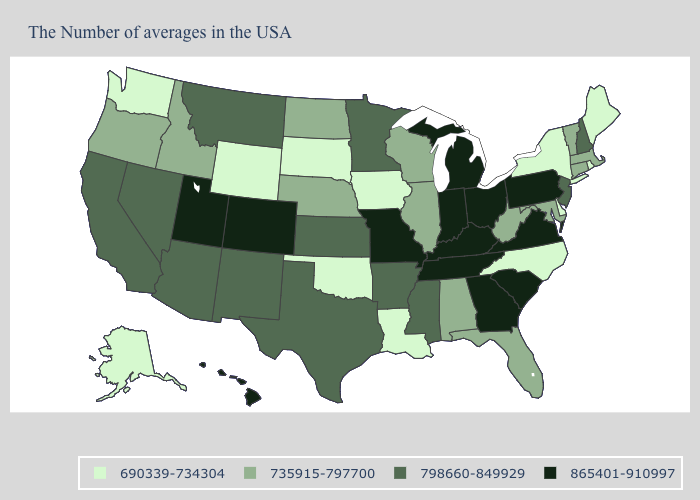Name the states that have a value in the range 865401-910997?
Concise answer only. Pennsylvania, Virginia, South Carolina, Ohio, Georgia, Michigan, Kentucky, Indiana, Tennessee, Missouri, Colorado, Utah, Hawaii. What is the value of Pennsylvania?
Keep it brief. 865401-910997. What is the value of Missouri?
Answer briefly. 865401-910997. How many symbols are there in the legend?
Be succinct. 4. Does Illinois have the same value as Vermont?
Be succinct. Yes. How many symbols are there in the legend?
Give a very brief answer. 4. Name the states that have a value in the range 735915-797700?
Short answer required. Massachusetts, Vermont, Connecticut, Maryland, West Virginia, Florida, Alabama, Wisconsin, Illinois, Nebraska, North Dakota, Idaho, Oregon. What is the highest value in the South ?
Quick response, please. 865401-910997. Which states have the highest value in the USA?
Be succinct. Pennsylvania, Virginia, South Carolina, Ohio, Georgia, Michigan, Kentucky, Indiana, Tennessee, Missouri, Colorado, Utah, Hawaii. What is the highest value in the USA?
Keep it brief. 865401-910997. What is the lowest value in the USA?
Short answer required. 690339-734304. Name the states that have a value in the range 735915-797700?
Keep it brief. Massachusetts, Vermont, Connecticut, Maryland, West Virginia, Florida, Alabama, Wisconsin, Illinois, Nebraska, North Dakota, Idaho, Oregon. Does Arkansas have a lower value than Virginia?
Keep it brief. Yes. Which states have the highest value in the USA?
Concise answer only. Pennsylvania, Virginia, South Carolina, Ohio, Georgia, Michigan, Kentucky, Indiana, Tennessee, Missouri, Colorado, Utah, Hawaii. 